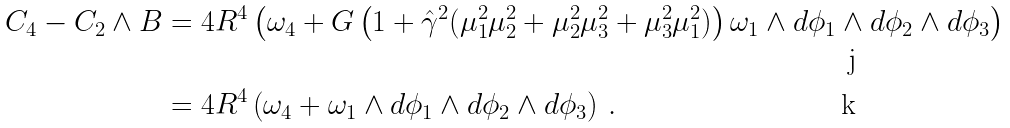<formula> <loc_0><loc_0><loc_500><loc_500>C _ { 4 } - C _ { 2 } \wedge B & = 4 R ^ { 4 } \left ( \omega _ { 4 } + G \left ( 1 + \hat { \gamma } ^ { 2 } ( \mu _ { 1 } ^ { 2 } \mu _ { 2 } ^ { 2 } + \mu _ { 2 } ^ { 2 } \mu _ { 3 } ^ { 2 } + \mu _ { 3 } ^ { 2 } \mu _ { 1 } ^ { 2 } ) \right ) \omega _ { 1 } \wedge d \phi _ { 1 } \wedge d \phi _ { 2 } \wedge d \phi _ { 3 } \right ) \\ & = 4 R ^ { 4 } \left ( \omega _ { 4 } + \omega _ { 1 } \wedge d \phi _ { 1 } \wedge d \phi _ { 2 } \wedge d \phi _ { 3 } \right ) \, .</formula> 